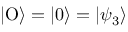<formula> <loc_0><loc_0><loc_500><loc_500>| O \rangle = | 0 \rangle = | \psi _ { 3 } \rangle</formula> 